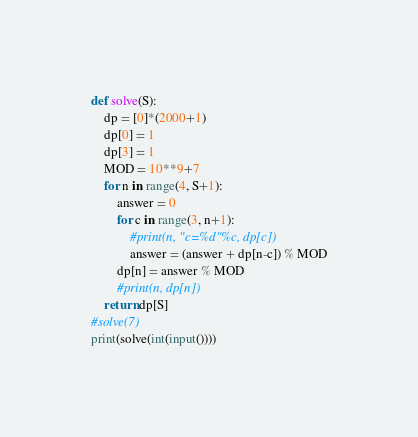<code> <loc_0><loc_0><loc_500><loc_500><_Python_>
def solve(S):
    dp = [0]*(2000+1)
    dp[0] = 1
    dp[3] = 1
    MOD = 10**9+7
    for n in range(4, S+1):
        answer = 0
        for c in range(3, n+1):
            #print(n, "c=%d"%c, dp[c])
            answer = (answer + dp[n-c]) % MOD
        dp[n] = answer % MOD
        #print(n, dp[n])
    return dp[S]
#solve(7)
print(solve(int(input())))
</code> 